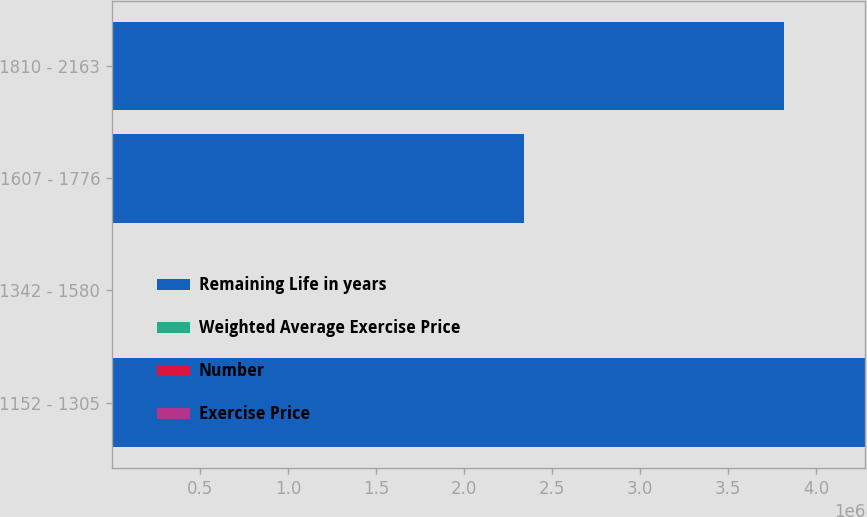Convert chart. <chart><loc_0><loc_0><loc_500><loc_500><stacked_bar_chart><ecel><fcel>1152 - 1305<fcel>1342 - 1580<fcel>1607 - 1776<fcel>1810 - 2163<nl><fcel>Remaining Life in years<fcel>4.28005e+06<fcel>14.91<fcel>2.34248e+06<fcel>3.81828e+06<nl><fcel>Weighted Average Exercise Price<fcel>7.1<fcel>7.5<fcel>3.3<fcel>2.4<nl><fcel>Number<fcel>12.78<fcel>14.23<fcel>16.95<fcel>18.28<nl><fcel>Exercise Price<fcel>12.7<fcel>14.91<fcel>16.95<fcel>18.28<nl></chart> 